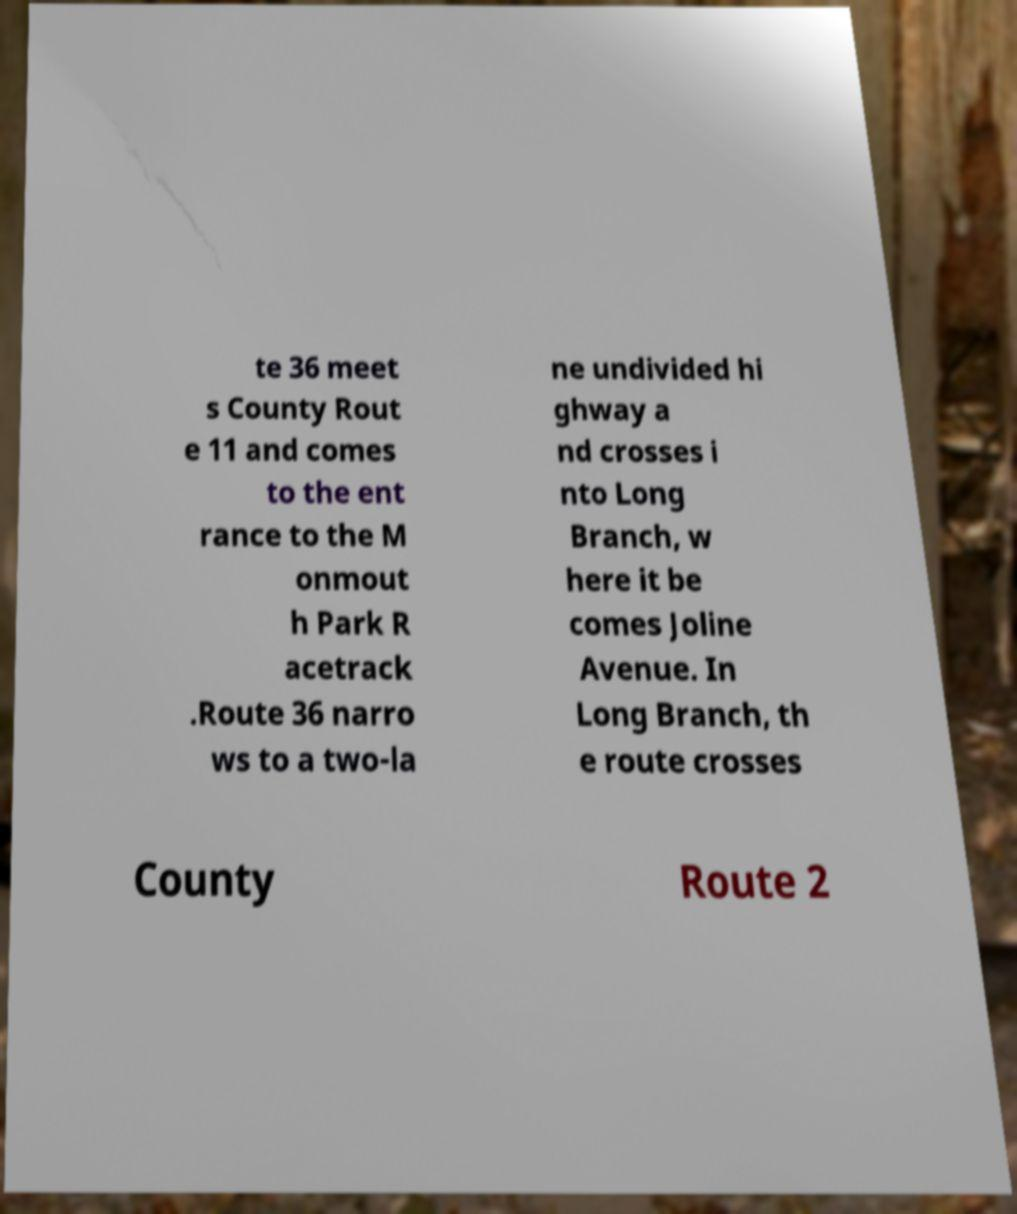Could you assist in decoding the text presented in this image and type it out clearly? te 36 meet s County Rout e 11 and comes to the ent rance to the M onmout h Park R acetrack .Route 36 narro ws to a two-la ne undivided hi ghway a nd crosses i nto Long Branch, w here it be comes Joline Avenue. In Long Branch, th e route crosses County Route 2 